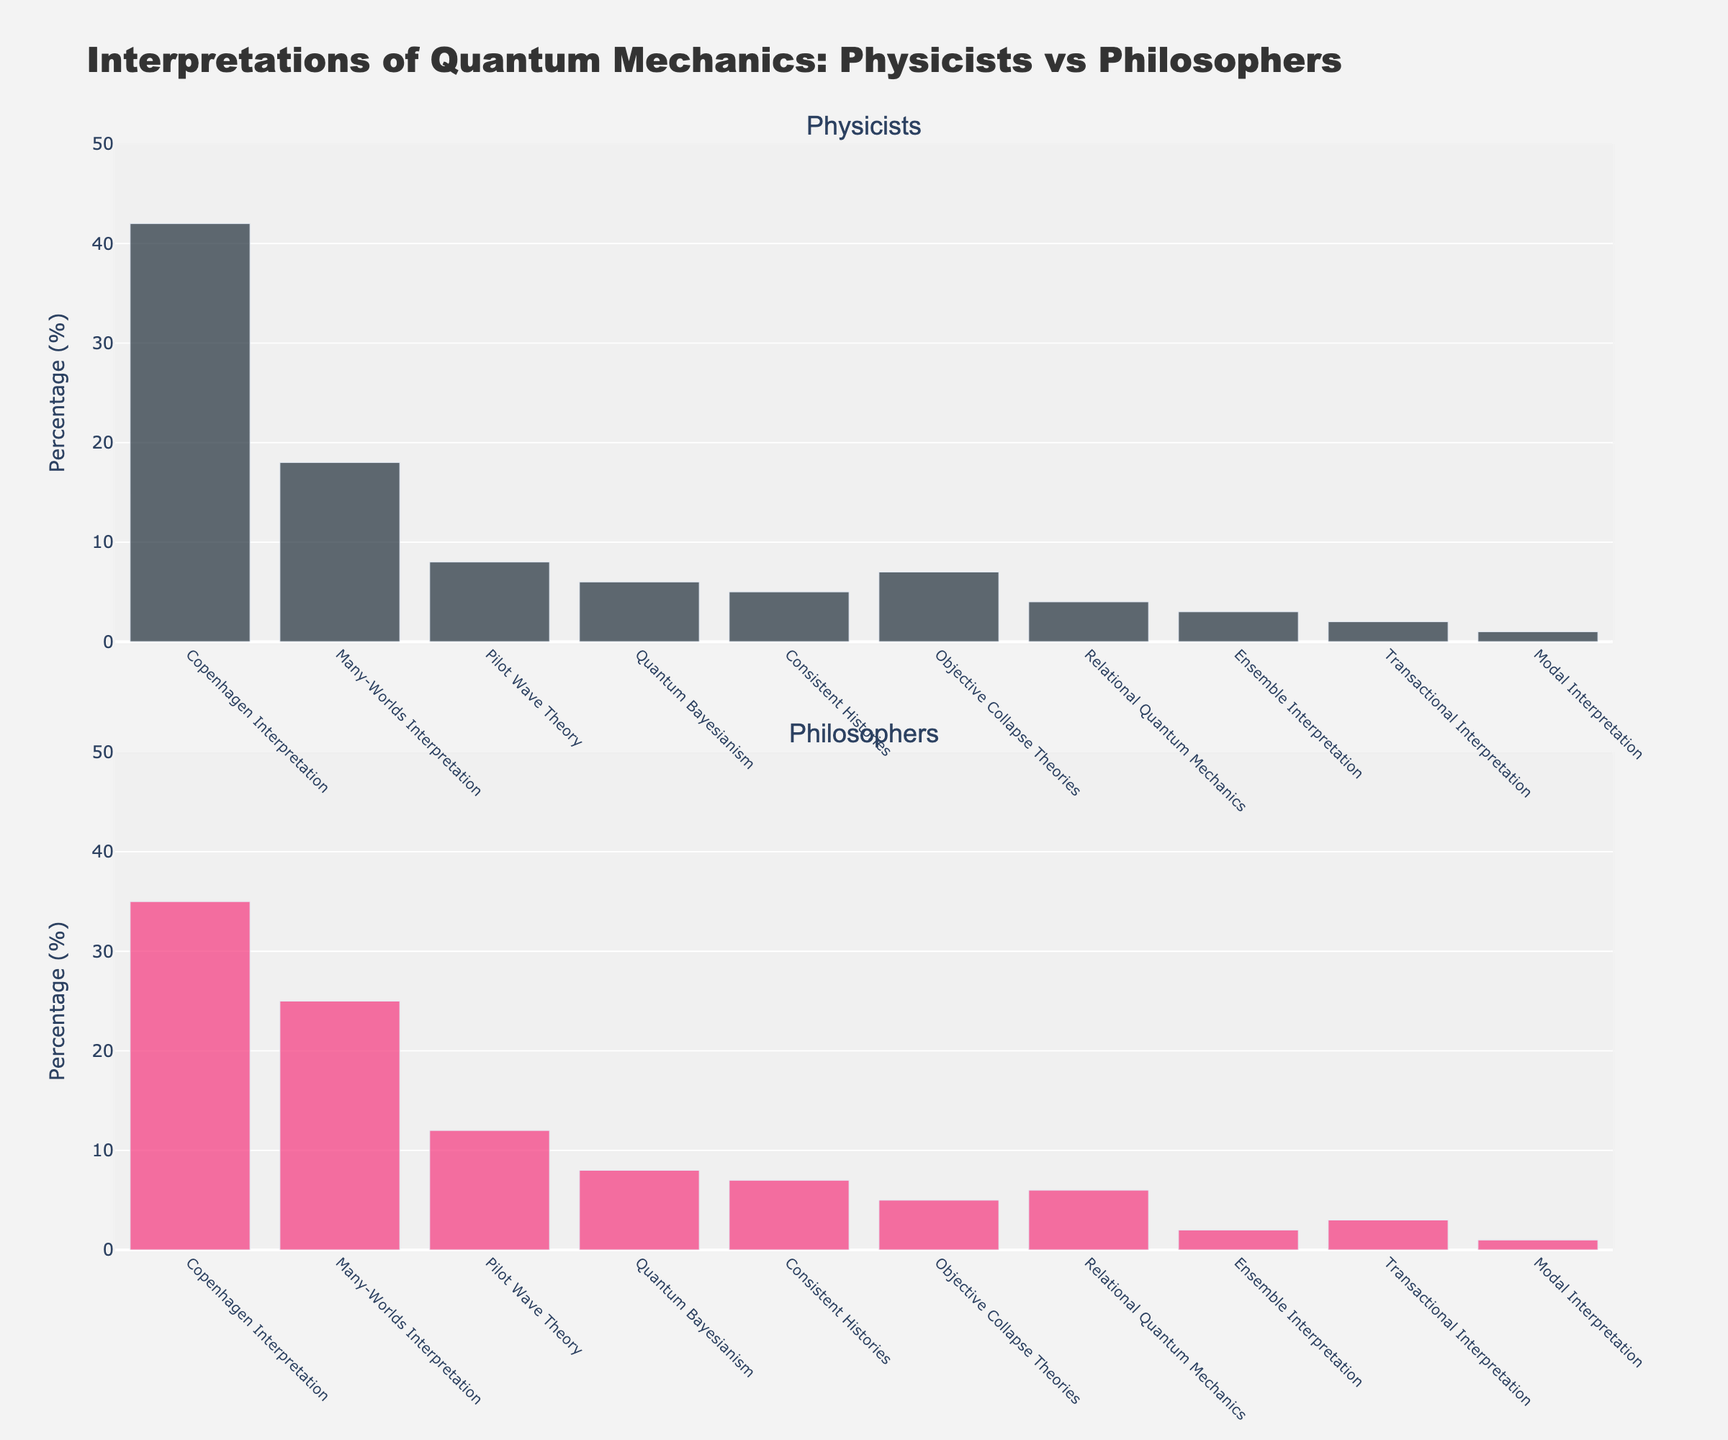What is the title of the figure? The title can be found at the top center of the figure and reads "Interpretations of Quantum Mechanics: Physicists vs Philosophers"
Answer: Interpretations of Quantum Mechanics: Physicists vs Philosophers Which interpretation is most popular among physicists? By examining the heights of the bars in the first subplot (Physicists), the tallest bar corresponds to the "Copenhagen Interpretation" with 42%.
Answer: Copenhagen Interpretation Which interpretation is the least popular among both physicists and philosophers? Both subplots show the lowest bar corresponds to the "Modal Interpretation", which is at 1% for both groups.
Answer: Modal Interpretation How much more popular is the Many-Worlds Interpretation among philosophers than physicists? From the second subplot (Philosophers), the Many-Worlds Interpretation is 25%. From the first subplot (Physicists), it's 18%. The difference is 25% - 18% = 7%.
Answer: 7% What is the sum of percentages for Quantum Bayesianism and Objective Collapse Theories among physicists? Quantum Bayesianism is at 6% and Objective Collapse Theories are at 7% in the first subplot (Physicists). The sum is 6% + 7% = 13%.
Answer: 13% Which interpretation has the largest difference in popularity between physicists and philosophers? By comparing the differences for each interpretation, the Many-Worlds Interpretation has the largest difference: 25% (Philosophers) - 18% (Physicists) = 7%.
Answer: Many-Worlds Interpretation How many interpretations have a higher percentage among philosophers compared to physicists? By checking each bar in both subplots, the interpretations with higher percentages for philosophers are: Many-Worlds Interpretation, Pilot Wave Theory, Quantum Bayesianism, Consistent Histories, Relational Quantum Mechanics, and Transactional Interpretation. There are 6 such interpretations.
Answer: 6 What is the average popularity of the Relational Quantum Mechanics interpretation among both groups? For physicists, it's 4% and for philosophers, it’s 6%. The average is (4% + 6%) / 2 = 5%.
Answer: 5% Compare the popularity of the Pilot Wave Theory and Ensemble Interpretation among physicists. Which one is more popular? From the first subplot (Physicists), the Pilot Wave Theory is at 8% and the Ensemble Interpretation is at 3%. The Pilot Wave Theory is more popular.
Answer: Pilot Wave Theory What is the combined percentage of the four least popular interpretations among philosophers? The least popular ones are Ensemble Interpretation (2%), Transactional Interpretation (3%), Modal Interpretation (1%), and Objective Collapse Theories (5%). The sum is 2% + 3% + 1% + 5% = 11%.
Answer: 11% How would you describe the overall trend in the popularity of different quantum interpretations between physicists and philosophers? The figure shows that while both groups favor the Copenhagen Interpretation most, philosophers tend to support a wider variety of interpretations more evenly compared to physicists who show a clear preference for a few interpretations.
Answer: Philosophers favor a more diverse set of interpretations 